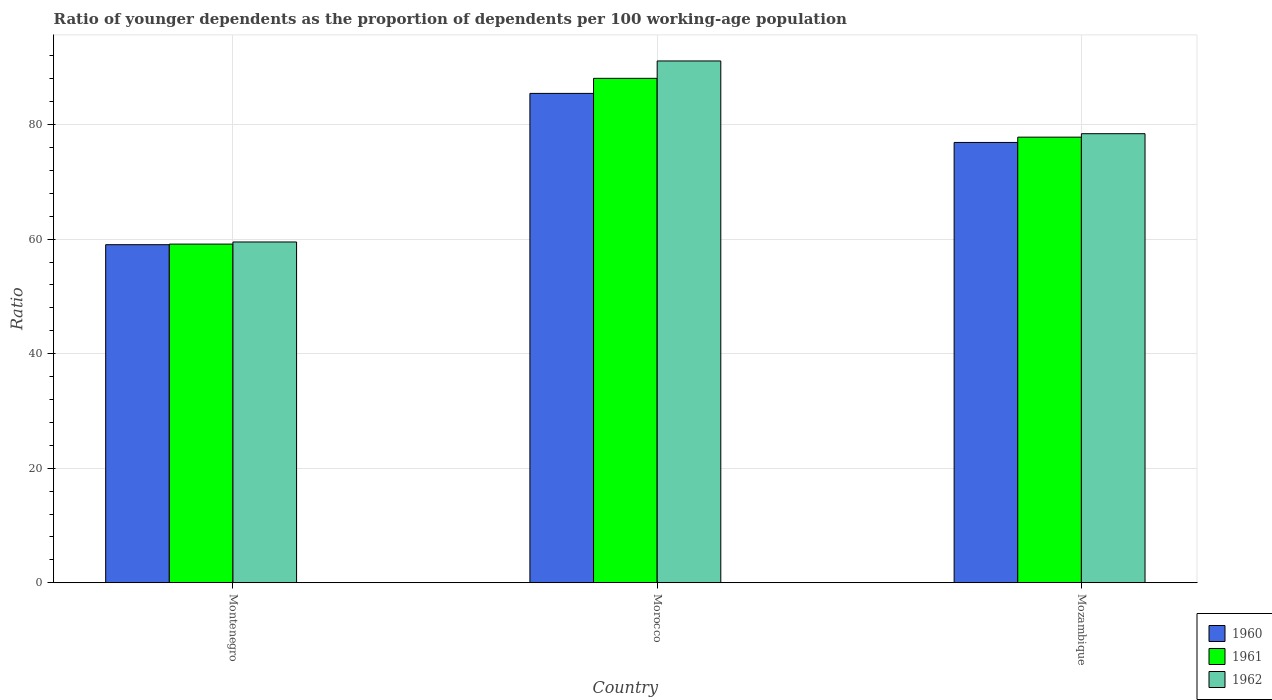How many bars are there on the 3rd tick from the left?
Provide a short and direct response. 3. How many bars are there on the 3rd tick from the right?
Provide a short and direct response. 3. What is the label of the 3rd group of bars from the left?
Provide a succinct answer. Mozambique. In how many cases, is the number of bars for a given country not equal to the number of legend labels?
Provide a succinct answer. 0. What is the age dependency ratio(young) in 1960 in Mozambique?
Offer a terse response. 76.89. Across all countries, what is the maximum age dependency ratio(young) in 1961?
Ensure brevity in your answer.  88.09. Across all countries, what is the minimum age dependency ratio(young) in 1960?
Give a very brief answer. 59.03. In which country was the age dependency ratio(young) in 1960 maximum?
Your answer should be very brief. Morocco. In which country was the age dependency ratio(young) in 1960 minimum?
Your answer should be very brief. Montenegro. What is the total age dependency ratio(young) in 1960 in the graph?
Your response must be concise. 221.38. What is the difference between the age dependency ratio(young) in 1960 in Montenegro and that in Morocco?
Your answer should be compact. -26.42. What is the difference between the age dependency ratio(young) in 1962 in Montenegro and the age dependency ratio(young) in 1960 in Morocco?
Offer a terse response. -25.95. What is the average age dependency ratio(young) in 1962 per country?
Make the answer very short. 76.35. What is the difference between the age dependency ratio(young) of/in 1961 and age dependency ratio(young) of/in 1962 in Morocco?
Your response must be concise. -3.04. What is the ratio of the age dependency ratio(young) in 1961 in Montenegro to that in Morocco?
Provide a succinct answer. 0.67. Is the difference between the age dependency ratio(young) in 1961 in Morocco and Mozambique greater than the difference between the age dependency ratio(young) in 1962 in Morocco and Mozambique?
Ensure brevity in your answer.  No. What is the difference between the highest and the second highest age dependency ratio(young) in 1960?
Offer a very short reply. -17.86. What is the difference between the highest and the lowest age dependency ratio(young) in 1961?
Offer a terse response. 28.95. Is the sum of the age dependency ratio(young) in 1962 in Montenegro and Morocco greater than the maximum age dependency ratio(young) in 1960 across all countries?
Your answer should be very brief. Yes. What does the 2nd bar from the left in Morocco represents?
Keep it short and to the point. 1961. What does the 2nd bar from the right in Montenegro represents?
Provide a short and direct response. 1961. Are all the bars in the graph horizontal?
Offer a very short reply. No. How many countries are there in the graph?
Your answer should be very brief. 3. Does the graph contain any zero values?
Provide a short and direct response. No. Where does the legend appear in the graph?
Your answer should be compact. Bottom right. How many legend labels are there?
Ensure brevity in your answer.  3. What is the title of the graph?
Offer a terse response. Ratio of younger dependents as the proportion of dependents per 100 working-age population. What is the label or title of the X-axis?
Ensure brevity in your answer.  Country. What is the label or title of the Y-axis?
Your answer should be very brief. Ratio. What is the Ratio of 1960 in Montenegro?
Your answer should be compact. 59.03. What is the Ratio of 1961 in Montenegro?
Keep it short and to the point. 59.14. What is the Ratio of 1962 in Montenegro?
Your answer should be compact. 59.51. What is the Ratio in 1960 in Morocco?
Offer a very short reply. 85.46. What is the Ratio in 1961 in Morocco?
Keep it short and to the point. 88.09. What is the Ratio in 1962 in Morocco?
Offer a terse response. 91.12. What is the Ratio in 1960 in Mozambique?
Make the answer very short. 76.89. What is the Ratio in 1961 in Mozambique?
Keep it short and to the point. 77.82. What is the Ratio of 1962 in Mozambique?
Provide a short and direct response. 78.42. Across all countries, what is the maximum Ratio in 1960?
Ensure brevity in your answer.  85.46. Across all countries, what is the maximum Ratio of 1961?
Keep it short and to the point. 88.09. Across all countries, what is the maximum Ratio in 1962?
Offer a very short reply. 91.12. Across all countries, what is the minimum Ratio of 1960?
Ensure brevity in your answer.  59.03. Across all countries, what is the minimum Ratio of 1961?
Give a very brief answer. 59.14. Across all countries, what is the minimum Ratio of 1962?
Your answer should be compact. 59.51. What is the total Ratio in 1960 in the graph?
Provide a succinct answer. 221.38. What is the total Ratio of 1961 in the graph?
Give a very brief answer. 225.04. What is the total Ratio in 1962 in the graph?
Give a very brief answer. 229.05. What is the difference between the Ratio of 1960 in Montenegro and that in Morocco?
Provide a short and direct response. -26.42. What is the difference between the Ratio of 1961 in Montenegro and that in Morocco?
Your response must be concise. -28.95. What is the difference between the Ratio of 1962 in Montenegro and that in Morocco?
Make the answer very short. -31.61. What is the difference between the Ratio of 1960 in Montenegro and that in Mozambique?
Give a very brief answer. -17.86. What is the difference between the Ratio in 1961 in Montenegro and that in Mozambique?
Give a very brief answer. -18.68. What is the difference between the Ratio of 1962 in Montenegro and that in Mozambique?
Your response must be concise. -18.91. What is the difference between the Ratio of 1960 in Morocco and that in Mozambique?
Give a very brief answer. 8.57. What is the difference between the Ratio of 1961 in Morocco and that in Mozambique?
Give a very brief answer. 10.27. What is the difference between the Ratio in 1962 in Morocco and that in Mozambique?
Give a very brief answer. 12.7. What is the difference between the Ratio of 1960 in Montenegro and the Ratio of 1961 in Morocco?
Keep it short and to the point. -29.05. What is the difference between the Ratio in 1960 in Montenegro and the Ratio in 1962 in Morocco?
Provide a succinct answer. -32.09. What is the difference between the Ratio of 1961 in Montenegro and the Ratio of 1962 in Morocco?
Make the answer very short. -31.98. What is the difference between the Ratio in 1960 in Montenegro and the Ratio in 1961 in Mozambique?
Give a very brief answer. -18.78. What is the difference between the Ratio in 1960 in Montenegro and the Ratio in 1962 in Mozambique?
Your answer should be very brief. -19.39. What is the difference between the Ratio in 1961 in Montenegro and the Ratio in 1962 in Mozambique?
Make the answer very short. -19.28. What is the difference between the Ratio of 1960 in Morocco and the Ratio of 1961 in Mozambique?
Offer a very short reply. 7.64. What is the difference between the Ratio of 1960 in Morocco and the Ratio of 1962 in Mozambique?
Offer a terse response. 7.04. What is the difference between the Ratio of 1961 in Morocco and the Ratio of 1962 in Mozambique?
Your answer should be very brief. 9.67. What is the average Ratio in 1960 per country?
Offer a terse response. 73.79. What is the average Ratio of 1961 per country?
Offer a very short reply. 75.01. What is the average Ratio in 1962 per country?
Your answer should be compact. 76.35. What is the difference between the Ratio in 1960 and Ratio in 1961 in Montenegro?
Give a very brief answer. -0.1. What is the difference between the Ratio in 1960 and Ratio in 1962 in Montenegro?
Your answer should be very brief. -0.48. What is the difference between the Ratio in 1961 and Ratio in 1962 in Montenegro?
Keep it short and to the point. -0.37. What is the difference between the Ratio of 1960 and Ratio of 1961 in Morocco?
Offer a very short reply. -2.63. What is the difference between the Ratio in 1960 and Ratio in 1962 in Morocco?
Ensure brevity in your answer.  -5.66. What is the difference between the Ratio in 1961 and Ratio in 1962 in Morocco?
Make the answer very short. -3.04. What is the difference between the Ratio in 1960 and Ratio in 1961 in Mozambique?
Make the answer very short. -0.93. What is the difference between the Ratio in 1960 and Ratio in 1962 in Mozambique?
Your response must be concise. -1.53. What is the difference between the Ratio of 1961 and Ratio of 1962 in Mozambique?
Your response must be concise. -0.6. What is the ratio of the Ratio of 1960 in Montenegro to that in Morocco?
Provide a short and direct response. 0.69. What is the ratio of the Ratio in 1961 in Montenegro to that in Morocco?
Keep it short and to the point. 0.67. What is the ratio of the Ratio in 1962 in Montenegro to that in Morocco?
Offer a terse response. 0.65. What is the ratio of the Ratio of 1960 in Montenegro to that in Mozambique?
Give a very brief answer. 0.77. What is the ratio of the Ratio of 1961 in Montenegro to that in Mozambique?
Give a very brief answer. 0.76. What is the ratio of the Ratio of 1962 in Montenegro to that in Mozambique?
Make the answer very short. 0.76. What is the ratio of the Ratio in 1960 in Morocco to that in Mozambique?
Your answer should be very brief. 1.11. What is the ratio of the Ratio of 1961 in Morocco to that in Mozambique?
Your answer should be compact. 1.13. What is the ratio of the Ratio of 1962 in Morocco to that in Mozambique?
Your answer should be compact. 1.16. What is the difference between the highest and the second highest Ratio in 1960?
Provide a short and direct response. 8.57. What is the difference between the highest and the second highest Ratio in 1961?
Your answer should be compact. 10.27. What is the difference between the highest and the second highest Ratio of 1962?
Provide a short and direct response. 12.7. What is the difference between the highest and the lowest Ratio in 1960?
Keep it short and to the point. 26.42. What is the difference between the highest and the lowest Ratio in 1961?
Your response must be concise. 28.95. What is the difference between the highest and the lowest Ratio in 1962?
Your answer should be very brief. 31.61. 